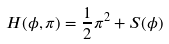Convert formula to latex. <formula><loc_0><loc_0><loc_500><loc_500>H ( \phi , \pi ) = \frac { 1 } { 2 } \pi ^ { 2 } + S ( \phi )</formula> 